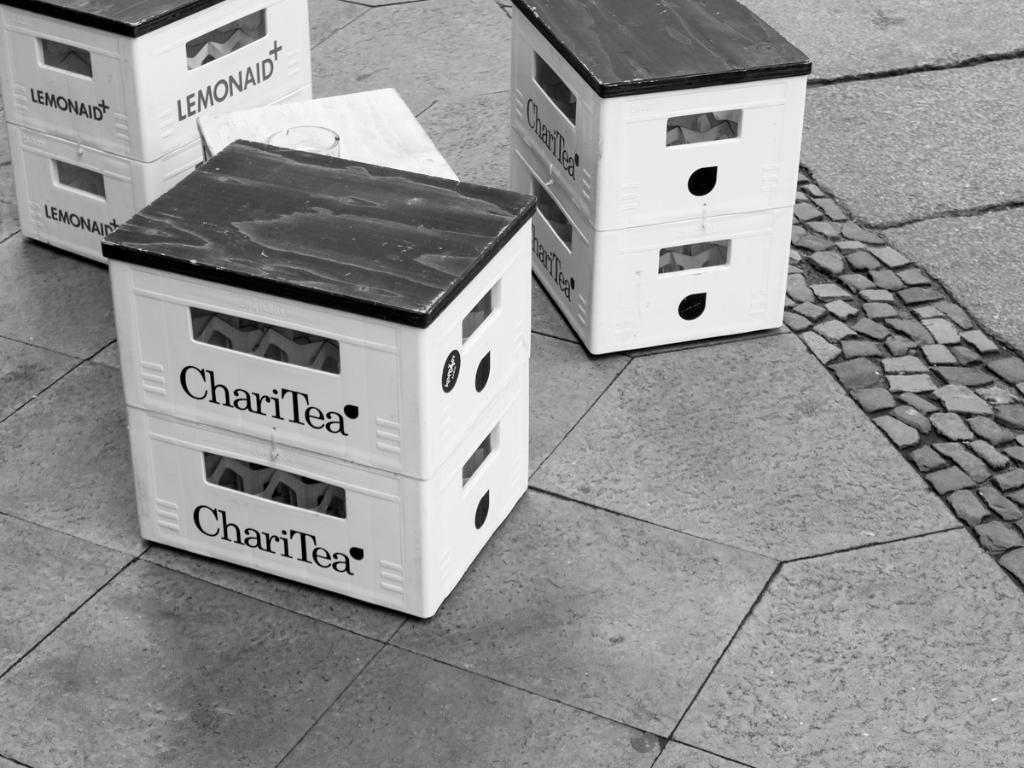<image>
Summarize the visual content of the image. Among two other crates is one marked ChariTea. 